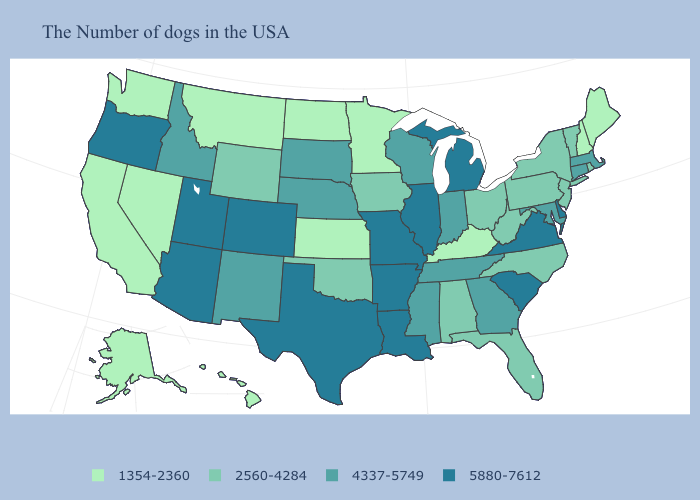How many symbols are there in the legend?
Be succinct. 4. Does the first symbol in the legend represent the smallest category?
Short answer required. Yes. What is the lowest value in the South?
Quick response, please. 1354-2360. Does the map have missing data?
Concise answer only. No. Which states have the lowest value in the USA?
Answer briefly. Maine, New Hampshire, Kentucky, Minnesota, Kansas, North Dakota, Montana, Nevada, California, Washington, Alaska, Hawaii. Name the states that have a value in the range 2560-4284?
Write a very short answer. Rhode Island, Vermont, New York, New Jersey, Pennsylvania, North Carolina, West Virginia, Ohio, Florida, Alabama, Iowa, Oklahoma, Wyoming. Which states have the lowest value in the USA?
Short answer required. Maine, New Hampshire, Kentucky, Minnesota, Kansas, North Dakota, Montana, Nevada, California, Washington, Alaska, Hawaii. Does the first symbol in the legend represent the smallest category?
Answer briefly. Yes. Is the legend a continuous bar?
Give a very brief answer. No. Among the states that border New Hampshire , does Vermont have the highest value?
Concise answer only. No. Name the states that have a value in the range 4337-5749?
Be succinct. Massachusetts, Connecticut, Maryland, Georgia, Indiana, Tennessee, Wisconsin, Mississippi, Nebraska, South Dakota, New Mexico, Idaho. Does the map have missing data?
Answer briefly. No. How many symbols are there in the legend?
Keep it brief. 4. Does Oregon have the highest value in the West?
Give a very brief answer. Yes. Which states hav the highest value in the South?
Quick response, please. Delaware, Virginia, South Carolina, Louisiana, Arkansas, Texas. 